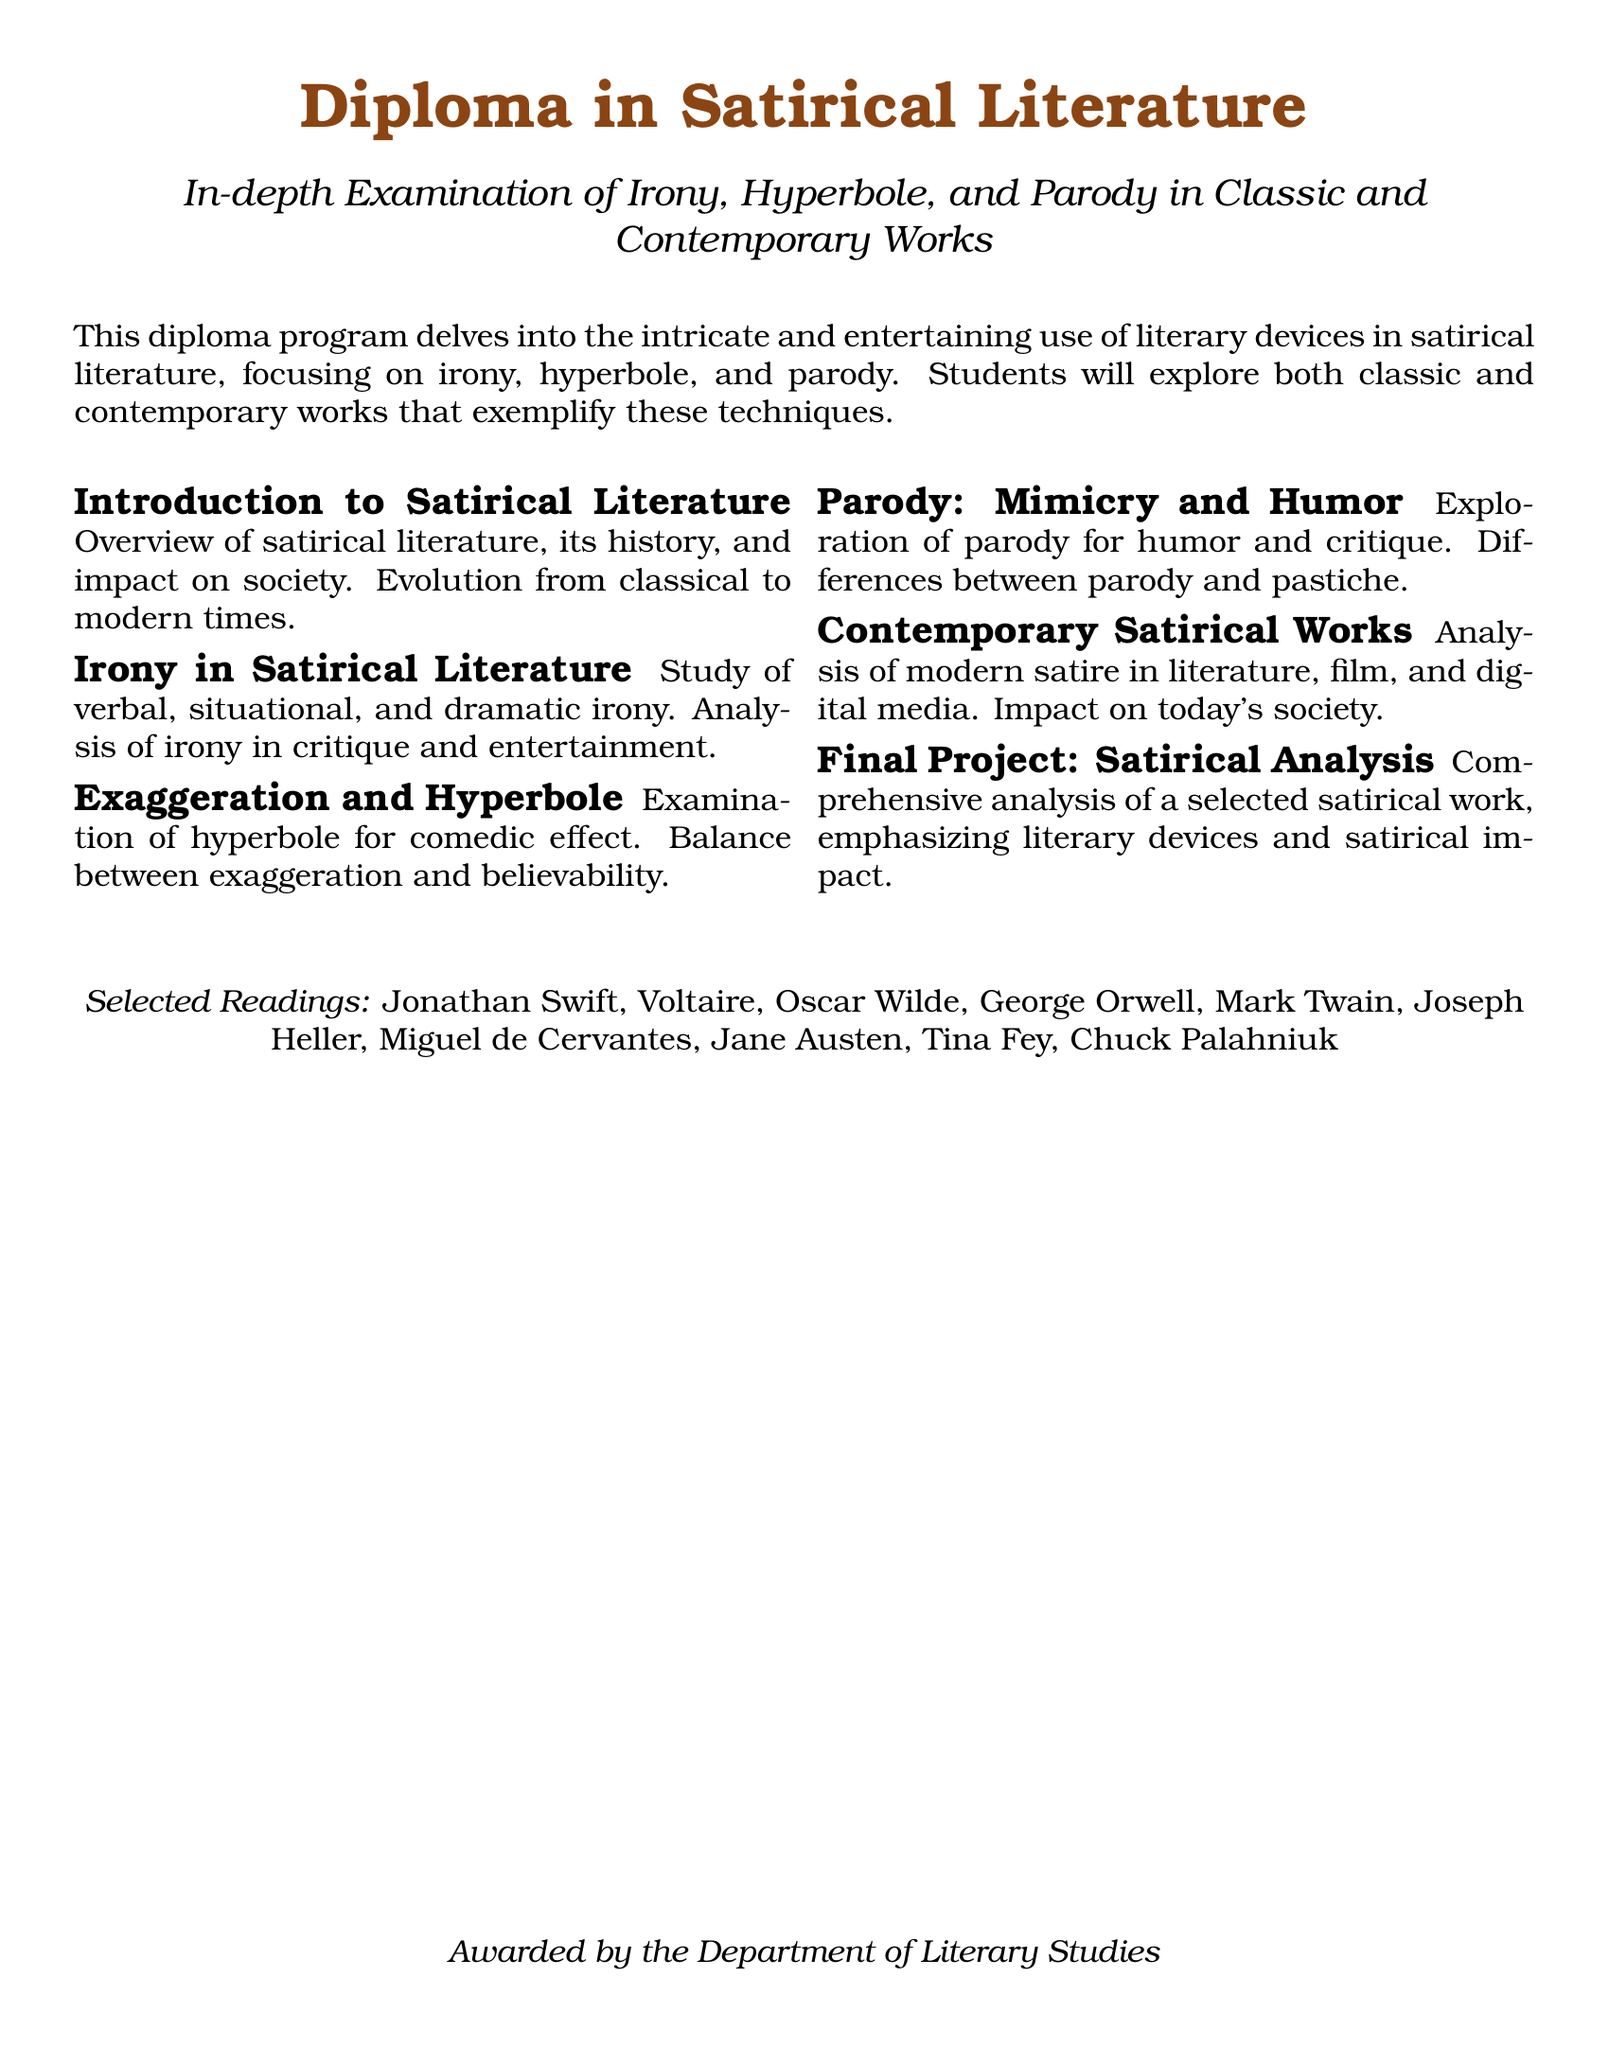What is the title of the diploma? The title of the diploma is prominently stated at the top of the document.
Answer: Diploma in Satirical Literature What are the three key literary devices studied in this diploma program? The document highlights the main literary devices in the program description.
Answer: Irony, Hyperbole, Parody Who are some of the selected authors for reading in this program? The document lists authors in the section about selected readings.
Answer: Jonathan Swift, Voltaire, Oscar Wilde What is the focus of the module on "Exaggeration and Hyperbole"? The document specifies what is examined in this module.
Answer: Hyperbole for comedic effect What is the final project about? The document describes the final project and its focus.
Answer: Comprehensive analysis of a selected satirical work How is modern satire explored in this diploma? The exploration of modern satire is mentioned under a specific module.
Answer: In literature, film, and digital media 